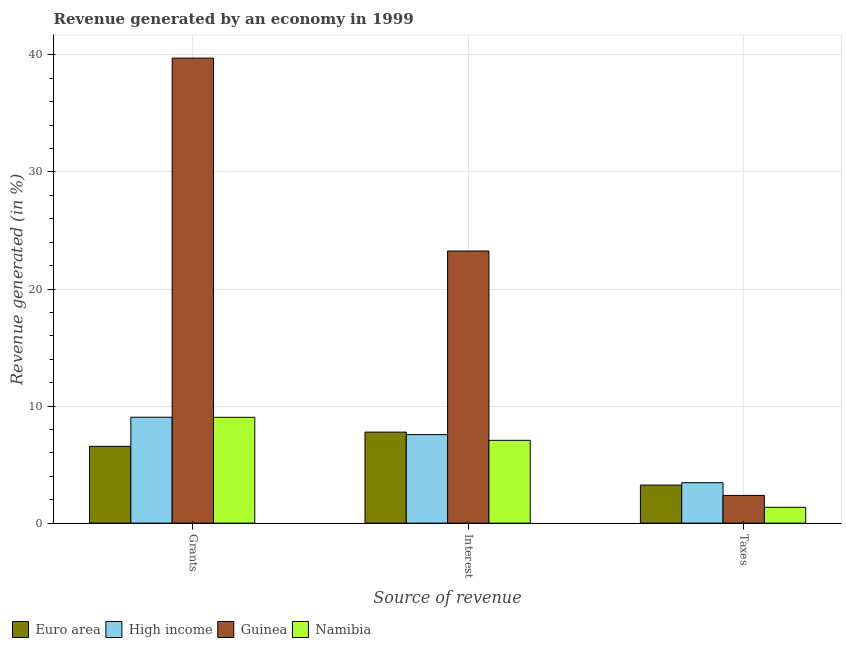How many different coloured bars are there?
Provide a succinct answer. 4. Are the number of bars per tick equal to the number of legend labels?
Your answer should be compact. Yes. Are the number of bars on each tick of the X-axis equal?
Ensure brevity in your answer.  Yes. What is the label of the 1st group of bars from the left?
Offer a terse response. Grants. What is the percentage of revenue generated by taxes in High income?
Make the answer very short. 3.45. Across all countries, what is the maximum percentage of revenue generated by grants?
Your response must be concise. 39.72. Across all countries, what is the minimum percentage of revenue generated by interest?
Make the answer very short. 7.07. In which country was the percentage of revenue generated by grants maximum?
Offer a terse response. Guinea. In which country was the percentage of revenue generated by taxes minimum?
Your answer should be very brief. Namibia. What is the total percentage of revenue generated by grants in the graph?
Ensure brevity in your answer.  64.37. What is the difference between the percentage of revenue generated by grants in High income and that in Euro area?
Offer a very short reply. 2.49. What is the difference between the percentage of revenue generated by taxes in Guinea and the percentage of revenue generated by grants in High income?
Provide a succinct answer. -6.68. What is the average percentage of revenue generated by taxes per country?
Your response must be concise. 2.6. What is the difference between the percentage of revenue generated by interest and percentage of revenue generated by grants in Guinea?
Ensure brevity in your answer.  -16.48. What is the ratio of the percentage of revenue generated by taxes in Guinea to that in Euro area?
Your answer should be very brief. 0.73. What is the difference between the highest and the second highest percentage of revenue generated by taxes?
Ensure brevity in your answer.  0.2. What is the difference between the highest and the lowest percentage of revenue generated by taxes?
Your answer should be very brief. 2.1. In how many countries, is the percentage of revenue generated by grants greater than the average percentage of revenue generated by grants taken over all countries?
Keep it short and to the point. 1. Is the sum of the percentage of revenue generated by interest in High income and Namibia greater than the maximum percentage of revenue generated by taxes across all countries?
Keep it short and to the point. Yes. What does the 3rd bar from the left in Interest represents?
Provide a short and direct response. Guinea. What does the 2nd bar from the right in Grants represents?
Your response must be concise. Guinea. Are all the bars in the graph horizontal?
Your answer should be compact. No. Are the values on the major ticks of Y-axis written in scientific E-notation?
Keep it short and to the point. No. Does the graph contain grids?
Your answer should be very brief. Yes. Where does the legend appear in the graph?
Keep it short and to the point. Bottom left. How are the legend labels stacked?
Provide a short and direct response. Horizontal. What is the title of the graph?
Provide a succinct answer. Revenue generated by an economy in 1999. Does "Channel Islands" appear as one of the legend labels in the graph?
Your response must be concise. No. What is the label or title of the X-axis?
Your answer should be compact. Source of revenue. What is the label or title of the Y-axis?
Make the answer very short. Revenue generated (in %). What is the Revenue generated (in %) of Euro area in Grants?
Ensure brevity in your answer.  6.56. What is the Revenue generated (in %) of High income in Grants?
Offer a terse response. 9.05. What is the Revenue generated (in %) in Guinea in Grants?
Make the answer very short. 39.72. What is the Revenue generated (in %) of Namibia in Grants?
Offer a very short reply. 9.04. What is the Revenue generated (in %) of Euro area in Interest?
Offer a terse response. 7.77. What is the Revenue generated (in %) in High income in Interest?
Provide a succinct answer. 7.56. What is the Revenue generated (in %) in Guinea in Interest?
Give a very brief answer. 23.25. What is the Revenue generated (in %) of Namibia in Interest?
Your response must be concise. 7.07. What is the Revenue generated (in %) of Euro area in Taxes?
Offer a terse response. 3.25. What is the Revenue generated (in %) of High income in Taxes?
Make the answer very short. 3.45. What is the Revenue generated (in %) of Guinea in Taxes?
Ensure brevity in your answer.  2.37. What is the Revenue generated (in %) in Namibia in Taxes?
Your answer should be very brief. 1.35. Across all Source of revenue, what is the maximum Revenue generated (in %) of Euro area?
Your response must be concise. 7.77. Across all Source of revenue, what is the maximum Revenue generated (in %) in High income?
Provide a succinct answer. 9.05. Across all Source of revenue, what is the maximum Revenue generated (in %) of Guinea?
Provide a short and direct response. 39.72. Across all Source of revenue, what is the maximum Revenue generated (in %) of Namibia?
Give a very brief answer. 9.04. Across all Source of revenue, what is the minimum Revenue generated (in %) in Euro area?
Give a very brief answer. 3.25. Across all Source of revenue, what is the minimum Revenue generated (in %) of High income?
Ensure brevity in your answer.  3.45. Across all Source of revenue, what is the minimum Revenue generated (in %) of Guinea?
Your answer should be compact. 2.37. Across all Source of revenue, what is the minimum Revenue generated (in %) in Namibia?
Give a very brief answer. 1.35. What is the total Revenue generated (in %) in Euro area in the graph?
Your response must be concise. 17.58. What is the total Revenue generated (in %) in High income in the graph?
Provide a short and direct response. 20.06. What is the total Revenue generated (in %) of Guinea in the graph?
Ensure brevity in your answer.  65.34. What is the total Revenue generated (in %) of Namibia in the graph?
Your answer should be compact. 17.46. What is the difference between the Revenue generated (in %) of Euro area in Grants and that in Interest?
Offer a terse response. -1.21. What is the difference between the Revenue generated (in %) of High income in Grants and that in Interest?
Keep it short and to the point. 1.48. What is the difference between the Revenue generated (in %) in Guinea in Grants and that in Interest?
Provide a short and direct response. 16.48. What is the difference between the Revenue generated (in %) of Namibia in Grants and that in Interest?
Your response must be concise. 1.97. What is the difference between the Revenue generated (in %) of Euro area in Grants and that in Taxes?
Your answer should be compact. 3.31. What is the difference between the Revenue generated (in %) in High income in Grants and that in Taxes?
Your answer should be very brief. 5.59. What is the difference between the Revenue generated (in %) of Guinea in Grants and that in Taxes?
Provide a short and direct response. 37.36. What is the difference between the Revenue generated (in %) in Namibia in Grants and that in Taxes?
Ensure brevity in your answer.  7.69. What is the difference between the Revenue generated (in %) of Euro area in Interest and that in Taxes?
Make the answer very short. 4.53. What is the difference between the Revenue generated (in %) of High income in Interest and that in Taxes?
Provide a short and direct response. 4.11. What is the difference between the Revenue generated (in %) in Guinea in Interest and that in Taxes?
Your answer should be very brief. 20.88. What is the difference between the Revenue generated (in %) in Namibia in Interest and that in Taxes?
Offer a very short reply. 5.72. What is the difference between the Revenue generated (in %) of Euro area in Grants and the Revenue generated (in %) of High income in Interest?
Provide a succinct answer. -1. What is the difference between the Revenue generated (in %) in Euro area in Grants and the Revenue generated (in %) in Guinea in Interest?
Offer a very short reply. -16.69. What is the difference between the Revenue generated (in %) in Euro area in Grants and the Revenue generated (in %) in Namibia in Interest?
Your answer should be very brief. -0.51. What is the difference between the Revenue generated (in %) of High income in Grants and the Revenue generated (in %) of Guinea in Interest?
Provide a succinct answer. -14.2. What is the difference between the Revenue generated (in %) in High income in Grants and the Revenue generated (in %) in Namibia in Interest?
Your response must be concise. 1.98. What is the difference between the Revenue generated (in %) in Guinea in Grants and the Revenue generated (in %) in Namibia in Interest?
Keep it short and to the point. 32.65. What is the difference between the Revenue generated (in %) in Euro area in Grants and the Revenue generated (in %) in High income in Taxes?
Your answer should be compact. 3.11. What is the difference between the Revenue generated (in %) of Euro area in Grants and the Revenue generated (in %) of Guinea in Taxes?
Your answer should be very brief. 4.19. What is the difference between the Revenue generated (in %) of Euro area in Grants and the Revenue generated (in %) of Namibia in Taxes?
Your answer should be very brief. 5.21. What is the difference between the Revenue generated (in %) in High income in Grants and the Revenue generated (in %) in Guinea in Taxes?
Offer a terse response. 6.68. What is the difference between the Revenue generated (in %) in High income in Grants and the Revenue generated (in %) in Namibia in Taxes?
Offer a terse response. 7.7. What is the difference between the Revenue generated (in %) in Guinea in Grants and the Revenue generated (in %) in Namibia in Taxes?
Your answer should be compact. 38.37. What is the difference between the Revenue generated (in %) of Euro area in Interest and the Revenue generated (in %) of High income in Taxes?
Offer a terse response. 4.32. What is the difference between the Revenue generated (in %) of Euro area in Interest and the Revenue generated (in %) of Guinea in Taxes?
Offer a very short reply. 5.41. What is the difference between the Revenue generated (in %) of Euro area in Interest and the Revenue generated (in %) of Namibia in Taxes?
Ensure brevity in your answer.  6.42. What is the difference between the Revenue generated (in %) of High income in Interest and the Revenue generated (in %) of Guinea in Taxes?
Offer a very short reply. 5.19. What is the difference between the Revenue generated (in %) of High income in Interest and the Revenue generated (in %) of Namibia in Taxes?
Provide a succinct answer. 6.21. What is the difference between the Revenue generated (in %) of Guinea in Interest and the Revenue generated (in %) of Namibia in Taxes?
Your answer should be very brief. 21.9. What is the average Revenue generated (in %) in Euro area per Source of revenue?
Your response must be concise. 5.86. What is the average Revenue generated (in %) of High income per Source of revenue?
Make the answer very short. 6.69. What is the average Revenue generated (in %) in Guinea per Source of revenue?
Offer a terse response. 21.78. What is the average Revenue generated (in %) of Namibia per Source of revenue?
Keep it short and to the point. 5.82. What is the difference between the Revenue generated (in %) in Euro area and Revenue generated (in %) in High income in Grants?
Your answer should be very brief. -2.49. What is the difference between the Revenue generated (in %) of Euro area and Revenue generated (in %) of Guinea in Grants?
Give a very brief answer. -33.16. What is the difference between the Revenue generated (in %) in Euro area and Revenue generated (in %) in Namibia in Grants?
Your response must be concise. -2.48. What is the difference between the Revenue generated (in %) in High income and Revenue generated (in %) in Guinea in Grants?
Keep it short and to the point. -30.68. What is the difference between the Revenue generated (in %) in High income and Revenue generated (in %) in Namibia in Grants?
Give a very brief answer. 0.01. What is the difference between the Revenue generated (in %) in Guinea and Revenue generated (in %) in Namibia in Grants?
Your response must be concise. 30.69. What is the difference between the Revenue generated (in %) in Euro area and Revenue generated (in %) in High income in Interest?
Provide a short and direct response. 0.21. What is the difference between the Revenue generated (in %) of Euro area and Revenue generated (in %) of Guinea in Interest?
Ensure brevity in your answer.  -15.47. What is the difference between the Revenue generated (in %) of Euro area and Revenue generated (in %) of Namibia in Interest?
Your answer should be very brief. 0.7. What is the difference between the Revenue generated (in %) of High income and Revenue generated (in %) of Guinea in Interest?
Offer a terse response. -15.69. What is the difference between the Revenue generated (in %) in High income and Revenue generated (in %) in Namibia in Interest?
Ensure brevity in your answer.  0.49. What is the difference between the Revenue generated (in %) of Guinea and Revenue generated (in %) of Namibia in Interest?
Offer a very short reply. 16.18. What is the difference between the Revenue generated (in %) of Euro area and Revenue generated (in %) of High income in Taxes?
Give a very brief answer. -0.2. What is the difference between the Revenue generated (in %) of Euro area and Revenue generated (in %) of Guinea in Taxes?
Ensure brevity in your answer.  0.88. What is the difference between the Revenue generated (in %) in Euro area and Revenue generated (in %) in Namibia in Taxes?
Your response must be concise. 1.9. What is the difference between the Revenue generated (in %) in High income and Revenue generated (in %) in Guinea in Taxes?
Keep it short and to the point. 1.08. What is the difference between the Revenue generated (in %) of High income and Revenue generated (in %) of Namibia in Taxes?
Ensure brevity in your answer.  2.1. What is the difference between the Revenue generated (in %) of Guinea and Revenue generated (in %) of Namibia in Taxes?
Your response must be concise. 1.02. What is the ratio of the Revenue generated (in %) in Euro area in Grants to that in Interest?
Offer a very short reply. 0.84. What is the ratio of the Revenue generated (in %) of High income in Grants to that in Interest?
Keep it short and to the point. 1.2. What is the ratio of the Revenue generated (in %) of Guinea in Grants to that in Interest?
Offer a terse response. 1.71. What is the ratio of the Revenue generated (in %) in Namibia in Grants to that in Interest?
Offer a very short reply. 1.28. What is the ratio of the Revenue generated (in %) of Euro area in Grants to that in Taxes?
Offer a terse response. 2.02. What is the ratio of the Revenue generated (in %) in High income in Grants to that in Taxes?
Keep it short and to the point. 2.62. What is the ratio of the Revenue generated (in %) in Guinea in Grants to that in Taxes?
Make the answer very short. 16.78. What is the ratio of the Revenue generated (in %) of Namibia in Grants to that in Taxes?
Offer a terse response. 6.69. What is the ratio of the Revenue generated (in %) of Euro area in Interest to that in Taxes?
Your response must be concise. 2.39. What is the ratio of the Revenue generated (in %) in High income in Interest to that in Taxes?
Provide a succinct answer. 2.19. What is the ratio of the Revenue generated (in %) of Guinea in Interest to that in Taxes?
Ensure brevity in your answer.  9.82. What is the ratio of the Revenue generated (in %) in Namibia in Interest to that in Taxes?
Keep it short and to the point. 5.23. What is the difference between the highest and the second highest Revenue generated (in %) in Euro area?
Keep it short and to the point. 1.21. What is the difference between the highest and the second highest Revenue generated (in %) of High income?
Your answer should be compact. 1.48. What is the difference between the highest and the second highest Revenue generated (in %) of Guinea?
Ensure brevity in your answer.  16.48. What is the difference between the highest and the second highest Revenue generated (in %) of Namibia?
Offer a terse response. 1.97. What is the difference between the highest and the lowest Revenue generated (in %) of Euro area?
Your answer should be compact. 4.53. What is the difference between the highest and the lowest Revenue generated (in %) of High income?
Offer a very short reply. 5.59. What is the difference between the highest and the lowest Revenue generated (in %) of Guinea?
Ensure brevity in your answer.  37.36. What is the difference between the highest and the lowest Revenue generated (in %) of Namibia?
Ensure brevity in your answer.  7.69. 